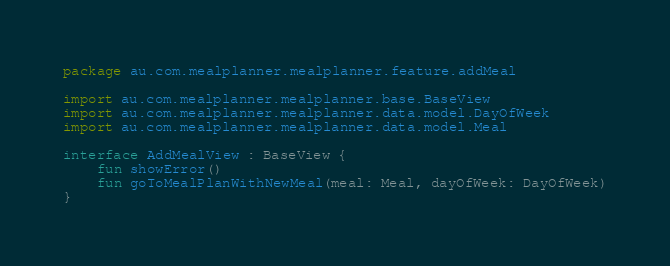<code> <loc_0><loc_0><loc_500><loc_500><_Kotlin_>package au.com.mealplanner.mealplanner.feature.addMeal

import au.com.mealplanner.mealplanner.base.BaseView
import au.com.mealplanner.mealplanner.data.model.DayOfWeek
import au.com.mealplanner.mealplanner.data.model.Meal

interface AddMealView : BaseView {
    fun showError()
    fun goToMealPlanWithNewMeal(meal: Meal, dayOfWeek: DayOfWeek)
}</code> 